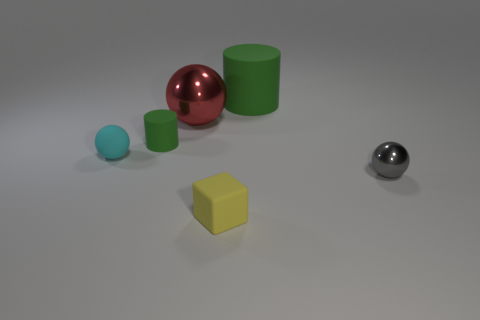How many things are either tiny yellow things or small balls?
Offer a terse response. 3. There is a big thing behind the metal thing that is left of the yellow object; what is its material?
Give a very brief answer. Rubber. How many cyan rubber objects have the same shape as the small metal thing?
Provide a succinct answer. 1. Are there any small things of the same color as the big matte thing?
Make the answer very short. Yes. How many objects are either tiny things that are in front of the tiny green matte cylinder or large red things that are to the right of the cyan ball?
Make the answer very short. 4. Is there a sphere that is on the right side of the block in front of the cyan object?
Your answer should be compact. Yes. The green rubber thing that is the same size as the gray metallic sphere is what shape?
Your response must be concise. Cylinder. What number of objects are spheres left of the gray shiny thing or cyan shiny things?
Your response must be concise. 2. How many other objects are the same material as the small cyan thing?
Provide a short and direct response. 3. What shape is the tiny object that is the same color as the big cylinder?
Your answer should be very brief. Cylinder. 